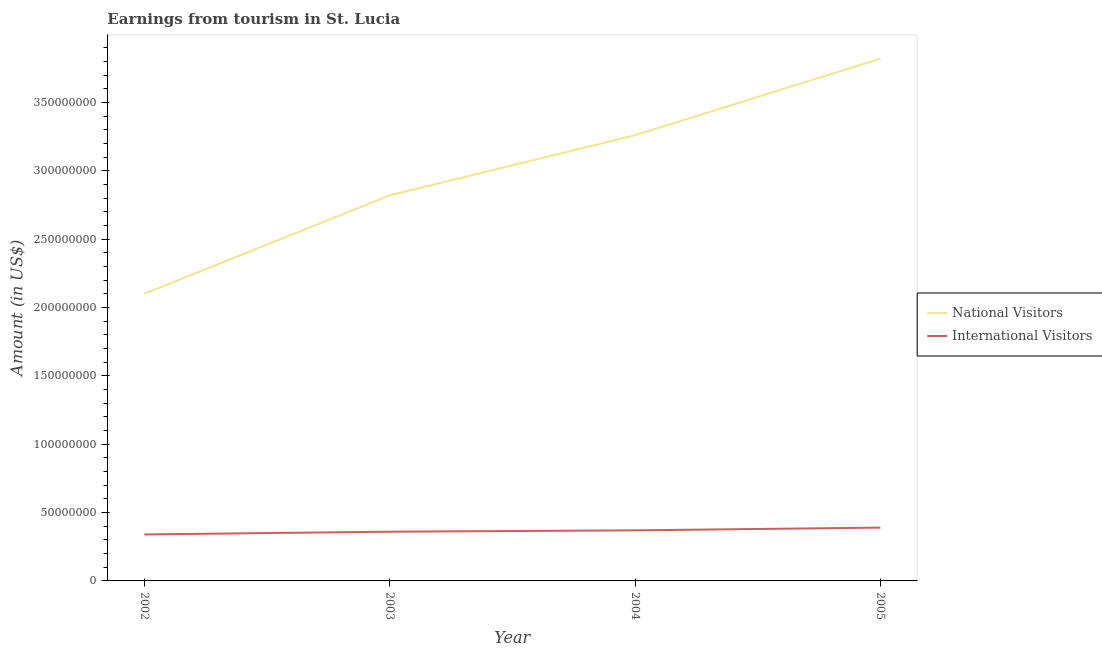Does the line corresponding to amount earned from international visitors intersect with the line corresponding to amount earned from national visitors?
Your response must be concise. No. What is the amount earned from international visitors in 2004?
Offer a very short reply. 3.70e+07. Across all years, what is the maximum amount earned from national visitors?
Your answer should be compact. 3.82e+08. Across all years, what is the minimum amount earned from national visitors?
Provide a short and direct response. 2.10e+08. In which year was the amount earned from international visitors maximum?
Provide a succinct answer. 2005. What is the total amount earned from national visitors in the graph?
Give a very brief answer. 1.20e+09. What is the difference between the amount earned from international visitors in 2002 and that in 2005?
Offer a very short reply. -5.00e+06. What is the difference between the amount earned from international visitors in 2004 and the amount earned from national visitors in 2005?
Your answer should be compact. -3.45e+08. What is the average amount earned from national visitors per year?
Your response must be concise. 3.00e+08. In the year 2005, what is the difference between the amount earned from national visitors and amount earned from international visitors?
Ensure brevity in your answer.  3.43e+08. What is the ratio of the amount earned from national visitors in 2004 to that in 2005?
Provide a succinct answer. 0.85. Is the amount earned from international visitors in 2002 less than that in 2005?
Give a very brief answer. Yes. What is the difference between the highest and the second highest amount earned from international visitors?
Your answer should be compact. 2.00e+06. What is the difference between the highest and the lowest amount earned from international visitors?
Make the answer very short. 5.00e+06. Does the amount earned from national visitors monotonically increase over the years?
Your answer should be very brief. Yes. Is the amount earned from international visitors strictly greater than the amount earned from national visitors over the years?
Offer a very short reply. No. Is the amount earned from national visitors strictly less than the amount earned from international visitors over the years?
Your response must be concise. No. How many lines are there?
Your response must be concise. 2. How many years are there in the graph?
Offer a very short reply. 4. What is the difference between two consecutive major ticks on the Y-axis?
Offer a very short reply. 5.00e+07. Does the graph contain grids?
Provide a short and direct response. No. How many legend labels are there?
Keep it short and to the point. 2. How are the legend labels stacked?
Ensure brevity in your answer.  Vertical. What is the title of the graph?
Keep it short and to the point. Earnings from tourism in St. Lucia. Does "Techinal cooperation" appear as one of the legend labels in the graph?
Your response must be concise. No. What is the label or title of the X-axis?
Your answer should be compact. Year. What is the label or title of the Y-axis?
Provide a succinct answer. Amount (in US$). What is the Amount (in US$) in National Visitors in 2002?
Give a very brief answer. 2.10e+08. What is the Amount (in US$) of International Visitors in 2002?
Your response must be concise. 3.40e+07. What is the Amount (in US$) in National Visitors in 2003?
Keep it short and to the point. 2.82e+08. What is the Amount (in US$) in International Visitors in 2003?
Provide a short and direct response. 3.60e+07. What is the Amount (in US$) in National Visitors in 2004?
Keep it short and to the point. 3.26e+08. What is the Amount (in US$) in International Visitors in 2004?
Ensure brevity in your answer.  3.70e+07. What is the Amount (in US$) of National Visitors in 2005?
Ensure brevity in your answer.  3.82e+08. What is the Amount (in US$) of International Visitors in 2005?
Your answer should be compact. 3.90e+07. Across all years, what is the maximum Amount (in US$) of National Visitors?
Ensure brevity in your answer.  3.82e+08. Across all years, what is the maximum Amount (in US$) of International Visitors?
Offer a terse response. 3.90e+07. Across all years, what is the minimum Amount (in US$) in National Visitors?
Make the answer very short. 2.10e+08. Across all years, what is the minimum Amount (in US$) in International Visitors?
Give a very brief answer. 3.40e+07. What is the total Amount (in US$) of National Visitors in the graph?
Keep it short and to the point. 1.20e+09. What is the total Amount (in US$) of International Visitors in the graph?
Provide a succinct answer. 1.46e+08. What is the difference between the Amount (in US$) of National Visitors in 2002 and that in 2003?
Make the answer very short. -7.20e+07. What is the difference between the Amount (in US$) in International Visitors in 2002 and that in 2003?
Provide a succinct answer. -2.00e+06. What is the difference between the Amount (in US$) in National Visitors in 2002 and that in 2004?
Ensure brevity in your answer.  -1.16e+08. What is the difference between the Amount (in US$) in National Visitors in 2002 and that in 2005?
Make the answer very short. -1.72e+08. What is the difference between the Amount (in US$) in International Visitors in 2002 and that in 2005?
Provide a succinct answer. -5.00e+06. What is the difference between the Amount (in US$) of National Visitors in 2003 and that in 2004?
Provide a succinct answer. -4.40e+07. What is the difference between the Amount (in US$) in National Visitors in 2003 and that in 2005?
Offer a very short reply. -1.00e+08. What is the difference between the Amount (in US$) in International Visitors in 2003 and that in 2005?
Your answer should be compact. -3.00e+06. What is the difference between the Amount (in US$) in National Visitors in 2004 and that in 2005?
Offer a terse response. -5.60e+07. What is the difference between the Amount (in US$) of National Visitors in 2002 and the Amount (in US$) of International Visitors in 2003?
Your answer should be compact. 1.74e+08. What is the difference between the Amount (in US$) of National Visitors in 2002 and the Amount (in US$) of International Visitors in 2004?
Offer a very short reply. 1.73e+08. What is the difference between the Amount (in US$) in National Visitors in 2002 and the Amount (in US$) in International Visitors in 2005?
Offer a very short reply. 1.71e+08. What is the difference between the Amount (in US$) in National Visitors in 2003 and the Amount (in US$) in International Visitors in 2004?
Keep it short and to the point. 2.45e+08. What is the difference between the Amount (in US$) of National Visitors in 2003 and the Amount (in US$) of International Visitors in 2005?
Make the answer very short. 2.43e+08. What is the difference between the Amount (in US$) of National Visitors in 2004 and the Amount (in US$) of International Visitors in 2005?
Offer a very short reply. 2.87e+08. What is the average Amount (in US$) of National Visitors per year?
Provide a short and direct response. 3.00e+08. What is the average Amount (in US$) in International Visitors per year?
Provide a short and direct response. 3.65e+07. In the year 2002, what is the difference between the Amount (in US$) of National Visitors and Amount (in US$) of International Visitors?
Provide a short and direct response. 1.76e+08. In the year 2003, what is the difference between the Amount (in US$) in National Visitors and Amount (in US$) in International Visitors?
Ensure brevity in your answer.  2.46e+08. In the year 2004, what is the difference between the Amount (in US$) of National Visitors and Amount (in US$) of International Visitors?
Keep it short and to the point. 2.89e+08. In the year 2005, what is the difference between the Amount (in US$) in National Visitors and Amount (in US$) in International Visitors?
Your answer should be compact. 3.43e+08. What is the ratio of the Amount (in US$) of National Visitors in 2002 to that in 2003?
Ensure brevity in your answer.  0.74. What is the ratio of the Amount (in US$) of International Visitors in 2002 to that in 2003?
Provide a succinct answer. 0.94. What is the ratio of the Amount (in US$) of National Visitors in 2002 to that in 2004?
Offer a terse response. 0.64. What is the ratio of the Amount (in US$) in International Visitors in 2002 to that in 2004?
Your answer should be compact. 0.92. What is the ratio of the Amount (in US$) of National Visitors in 2002 to that in 2005?
Offer a very short reply. 0.55. What is the ratio of the Amount (in US$) in International Visitors in 2002 to that in 2005?
Offer a very short reply. 0.87. What is the ratio of the Amount (in US$) in National Visitors in 2003 to that in 2004?
Offer a very short reply. 0.86. What is the ratio of the Amount (in US$) in National Visitors in 2003 to that in 2005?
Offer a terse response. 0.74. What is the ratio of the Amount (in US$) in National Visitors in 2004 to that in 2005?
Provide a succinct answer. 0.85. What is the ratio of the Amount (in US$) in International Visitors in 2004 to that in 2005?
Offer a terse response. 0.95. What is the difference between the highest and the second highest Amount (in US$) of National Visitors?
Offer a terse response. 5.60e+07. What is the difference between the highest and the second highest Amount (in US$) of International Visitors?
Make the answer very short. 2.00e+06. What is the difference between the highest and the lowest Amount (in US$) of National Visitors?
Keep it short and to the point. 1.72e+08. 